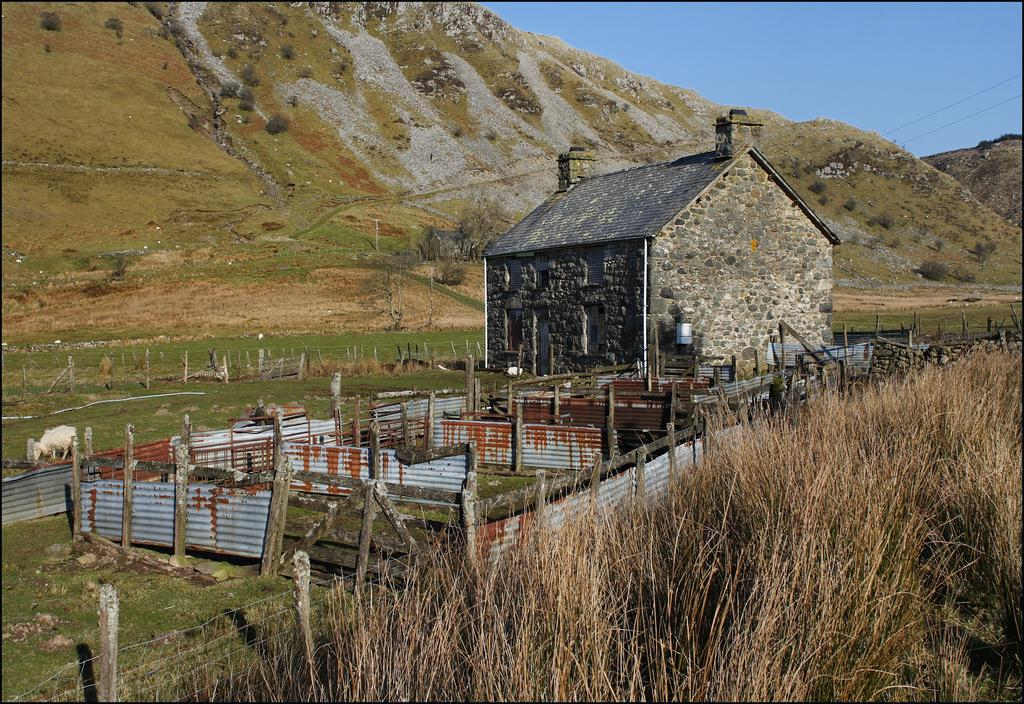What type of fencing is visible in the image? There is a grass fencing in the image. What structure is located in the middle of the image? There is a house in the middle of the image. What can be seen in the background of the image? There is a mountain and the sky visible in the background of the image. How many sheep are standing on the heart in the image? There are no sheep or hearts present in the image. What type of lift can be seen in the image? There is no lift present in the image. 